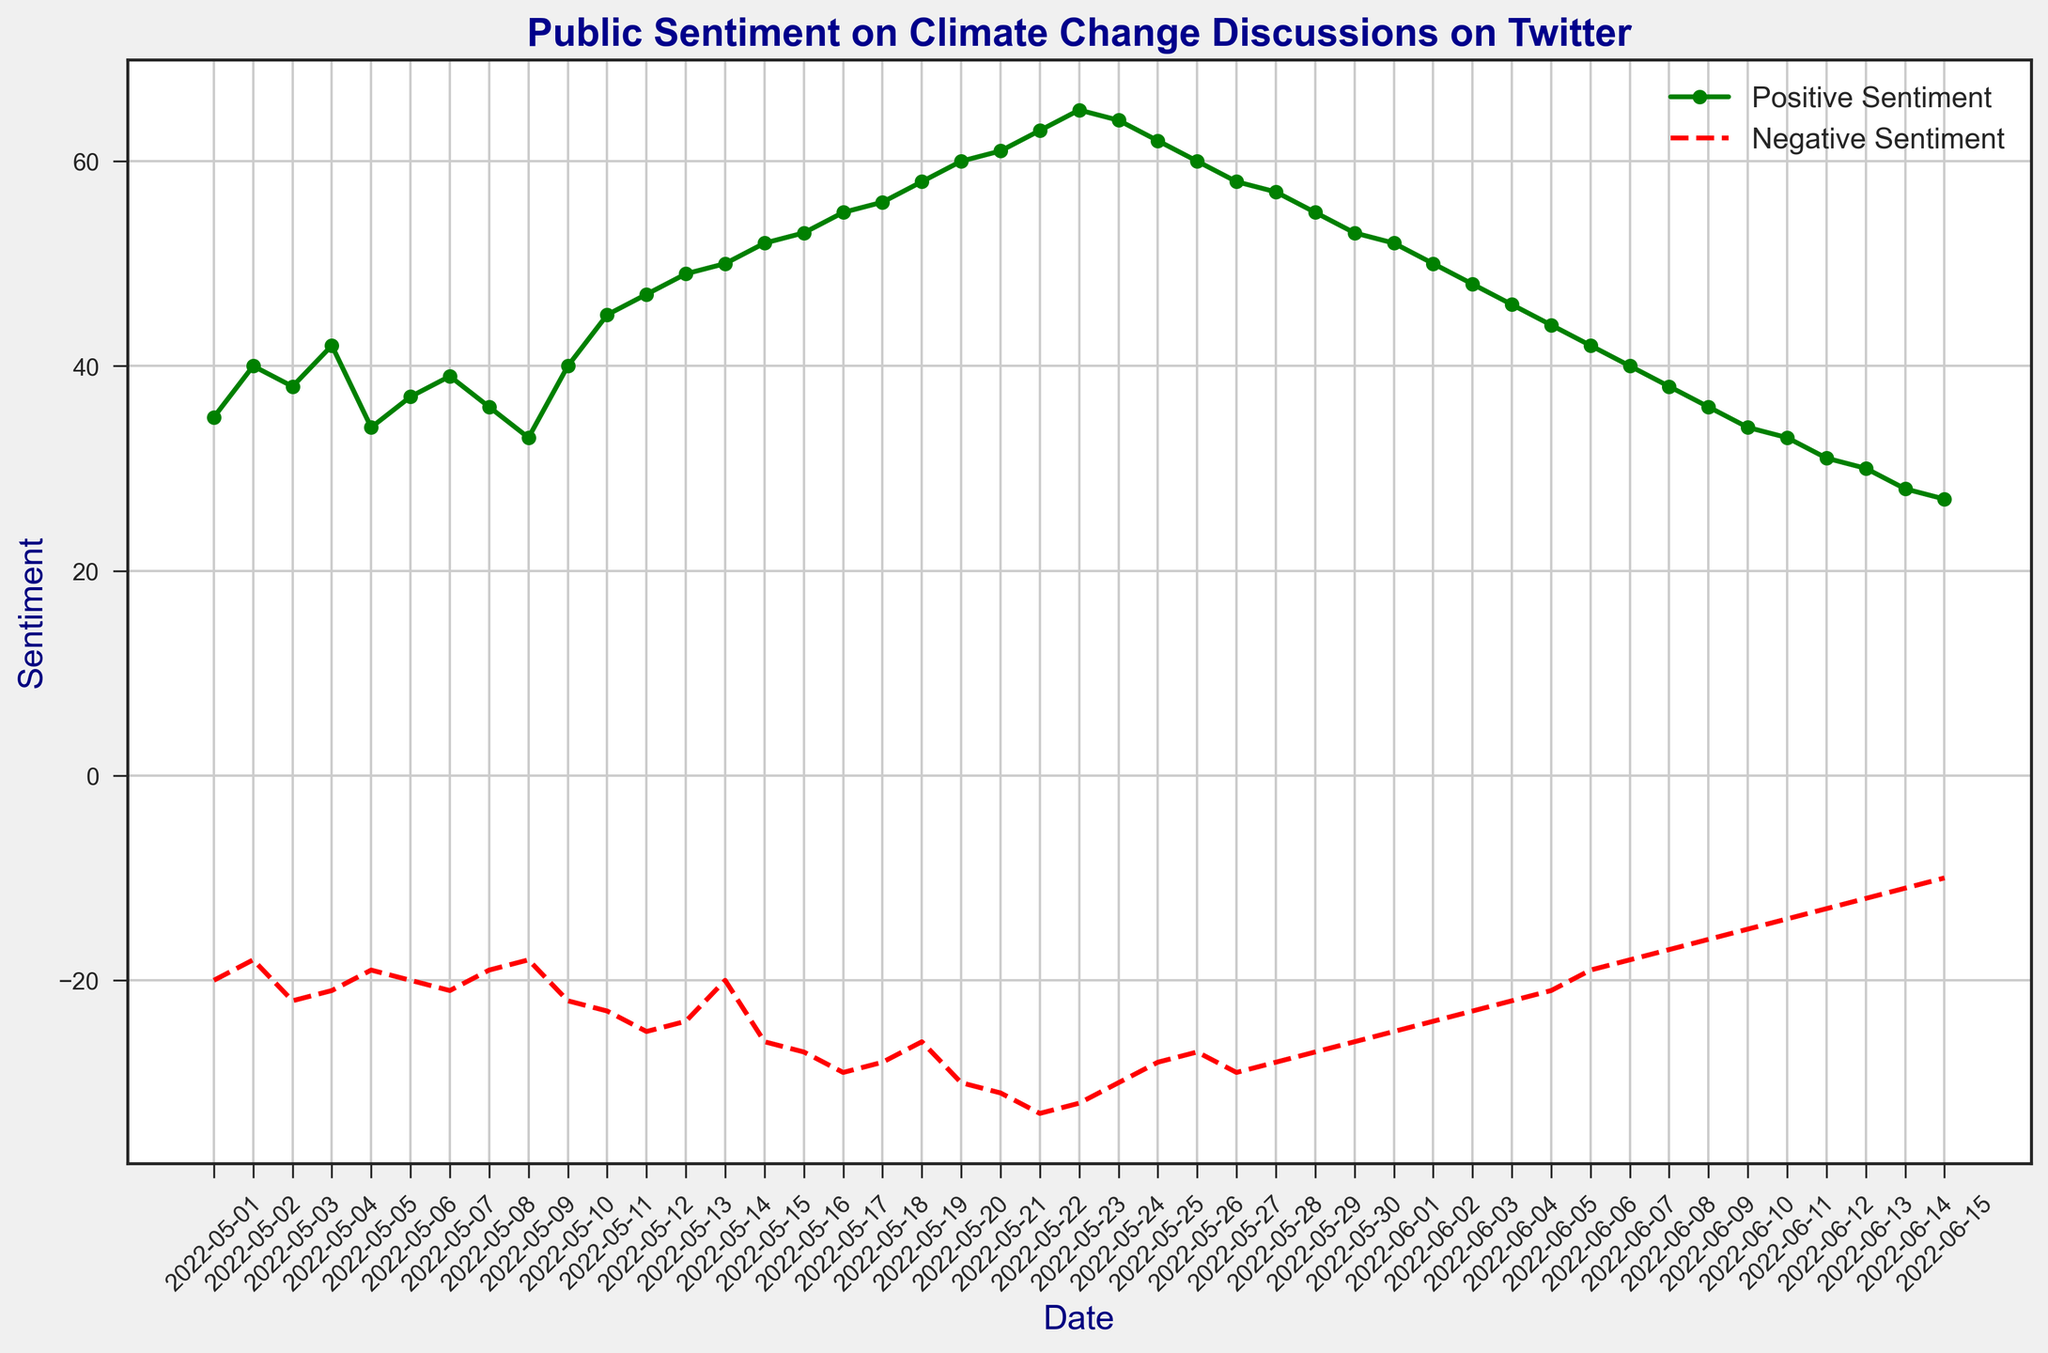What dates show the highest positive sentiment? By looking at the green line's peak, we can see that it reaches the highest level at 65 on May 23.
Answer: May 23 What is the trend in negative sentiment from May 12 to May 20? Observing the red dashed line between these dates, the negative sentiment generally increases from -25 on May 12 to -30 on May 20.
Answer: Increasing How does the positive sentiment on May 11 compare to the negative sentiment on the same day? On May 11, the green line (positive sentiment) is at 45, while the red line (negative sentiment) is at -23. Comparing these, positive sentiment is higher than negative sentiment.
Answer: Positive sentiment is higher Which date shows both positive and negative sentiments decreasing simultaneously? By tracking the lines together, on June 2 both positive sentiment (decreasing from 52 to 50) and negative sentiment (decreasing from -25 to -24) are lower than the previous day.
Answer: June 2 During which date range is positive sentiment above 50 while negative sentiment is below -30? The green line stays above 50 from May 15 to May 24, and during this period the red line crosses -30 only from May 19 to May 24.
Answer: May 19 - May 24 